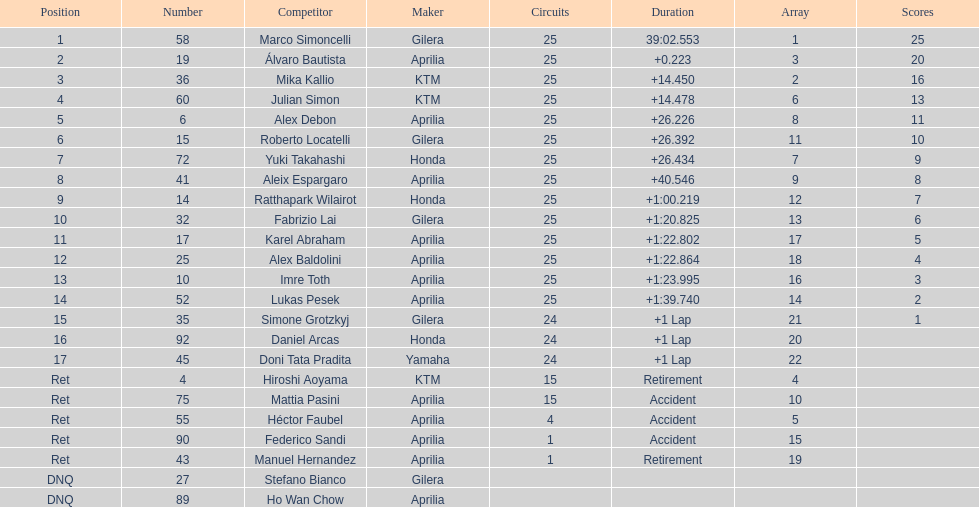The next rider from italy aside from winner marco simoncelli was Roberto Locatelli. 